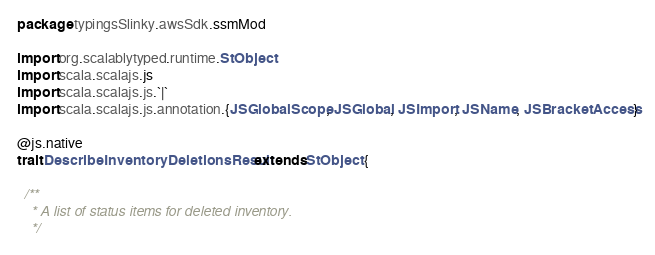Convert code to text. <code><loc_0><loc_0><loc_500><loc_500><_Scala_>package typingsSlinky.awsSdk.ssmMod

import org.scalablytyped.runtime.StObject
import scala.scalajs.js
import scala.scalajs.js.`|`
import scala.scalajs.js.annotation.{JSGlobalScope, JSGlobal, JSImport, JSName, JSBracketAccess}

@js.native
trait DescribeInventoryDeletionsResult extends StObject {
  
  /**
    * A list of status items for deleted inventory.
    */</code> 